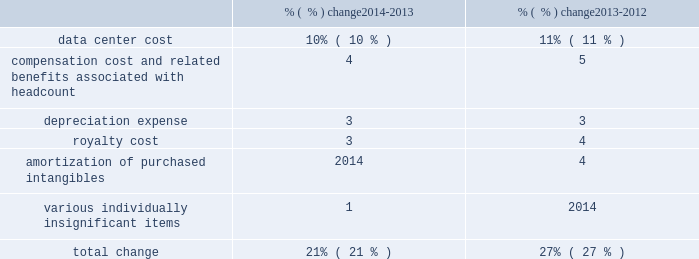Subscription cost of subscription revenue consists of third-party royalties and expenses related to operating our network infrastructure , including depreciation expenses and operating lease payments associated with computer equipment , data center costs , salaries and related expenses of network operations , implementation , account management and technical support personnel , amortization of intangible assets and allocated overhead .
We enter into contracts with third-parties for the use of their data center facilities and our data center costs largely consist of the amounts we pay to these third parties for rack space , power and similar items .
Cost of subscription revenue increased due to the following : % (  % ) change 2014-2013 % (  % ) change 2013-2012 .
Cost of subscription revenue increased during fiscal 2014 as compared to fiscal 2013 primarily due to data center costs , compensation cost and related benefits , deprecation expense , and royalty cost .
Data center costs increased as compared with the year-ago period primarily due to higher transaction volumes in our adobe marketing cloud and creative cloud services .
Compensation cost and related benefits increased as compared to the year-ago period primarily due to additional headcount in fiscal 2014 , including from our acquisition of neolane in the third quarter of fiscal 2013 .
Depreciation expense increased as compared to the year-ago period primarily due to higher capital expenditures in recent periods as we continue to invest in our network and data center infrastructure to support the growth of our business .
Royalty cost increased primarily due to increases in subscriptions and downloads of our saas offerings .
Cost of subscription revenue increased during fiscal 2013 as compared to fiscal 2012 primarily due to increased hosted server costs and amortization of purchased intangibles .
Hosted server costs increased primarily due to increases in data center costs related to higher transaction volumes in our adobe marketing cloud and creative cloud services , depreciation expense from higher capital expenditures in prior years and compensation and related benefits driven by additional headcount .
Amortization of purchased intangibles increased primarily due to increased amortization of intangible assets purchased associated with our acquisitions of behance and neolane in fiscal 2013 .
Services and support cost of services and support revenue is primarily comprised of employee-related costs and associated costs incurred to provide consulting services , training and product support .
Cost of services and support revenue increased during fiscal 2014 as compared to fiscal 2013 primarily due to increases in compensation and related benefits driven by additional headcount and third-party fees related to training and consulting services provided to our customers .
Cost of services and support revenue increased during fiscal 2013 as compared to fiscal 2012 primarily due to increases in third-party fees related to training and consulting services provided to our customers and compensation and related benefits driven by additional headcount , including headcount from our acquisition of neolane in fiscal 2013. .
From the years 2014-2013 to 2013-2012 , what was the change in percentage points of depreciation expense? 
Computations: (3 - 3)
Answer: 0.0. 